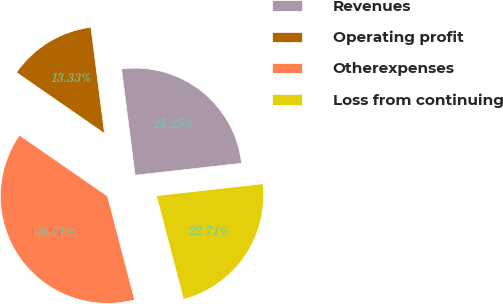<chart> <loc_0><loc_0><loc_500><loc_500><pie_chart><fcel>Revenues<fcel>Operating profit<fcel>Otherexpenses<fcel>Loss from continuing<nl><fcel>25.25%<fcel>13.33%<fcel>38.71%<fcel>22.71%<nl></chart> 